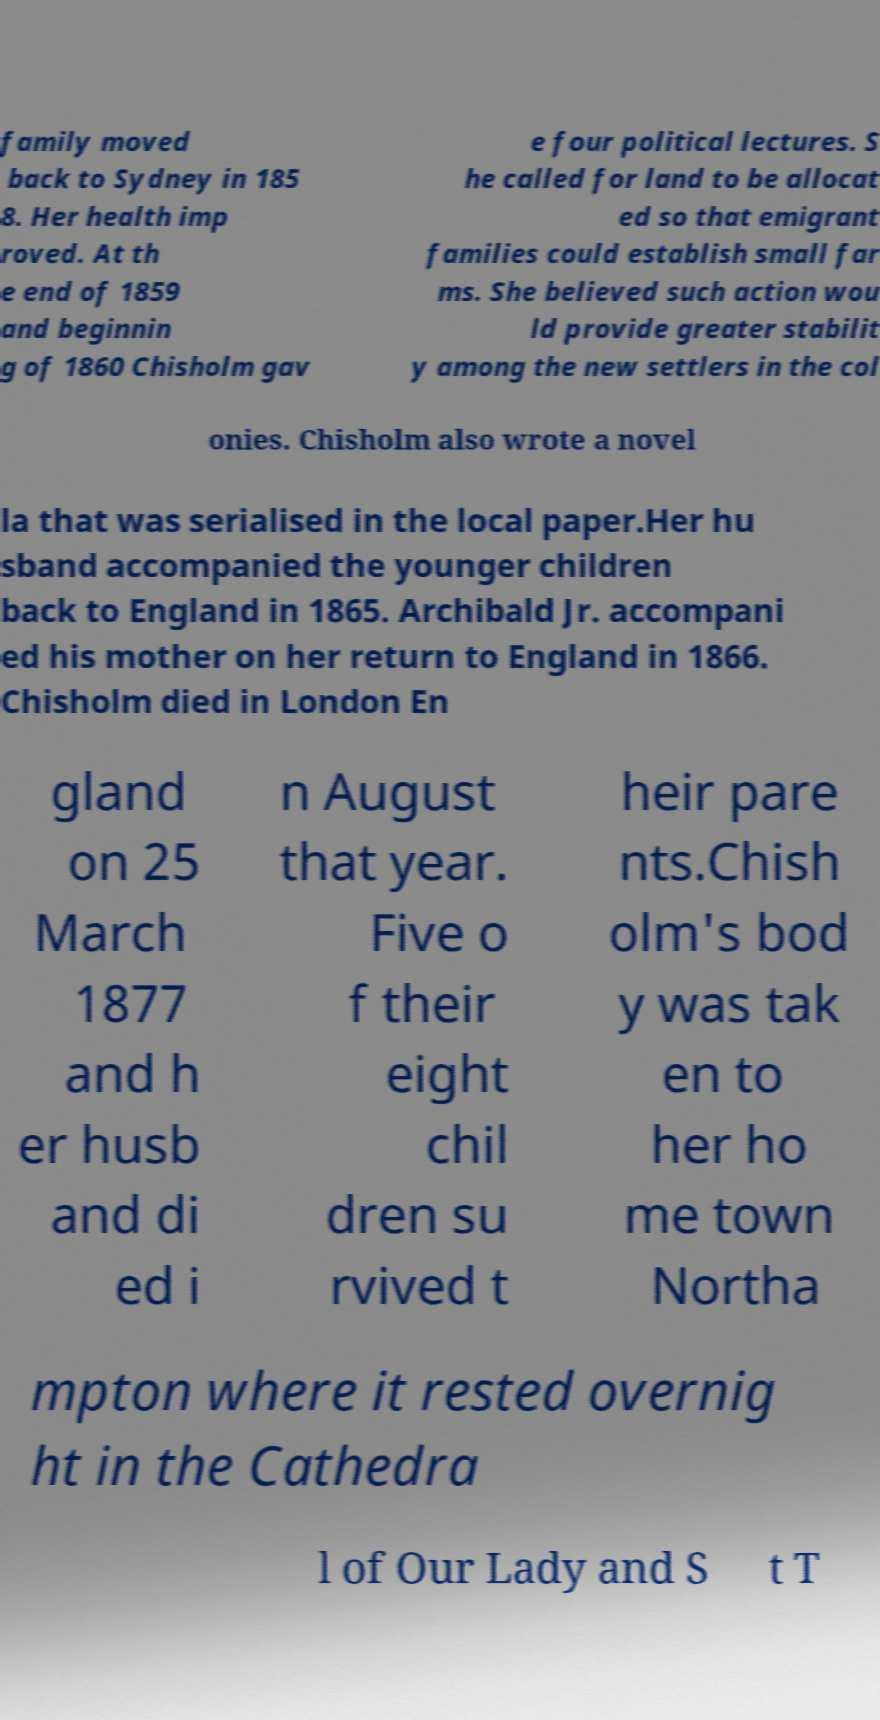What messages or text are displayed in this image? I need them in a readable, typed format. family moved back to Sydney in 185 8. Her health imp roved. At th e end of 1859 and beginnin g of 1860 Chisholm gav e four political lectures. S he called for land to be allocat ed so that emigrant families could establish small far ms. She believed such action wou ld provide greater stabilit y among the new settlers in the col onies. Chisholm also wrote a novel la that was serialised in the local paper.Her hu sband accompanied the younger children back to England in 1865. Archibald Jr. accompani ed his mother on her return to England in 1866. Chisholm died in London En gland on 25 March 1877 and h er husb and di ed i n August that year. Five o f their eight chil dren su rvived t heir pare nts.Chish olm's bod y was tak en to her ho me town Northa mpton where it rested overnig ht in the Cathedra l of Our Lady and S t T 